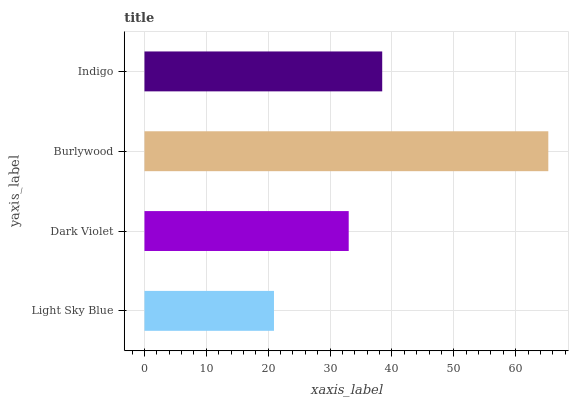Is Light Sky Blue the minimum?
Answer yes or no. Yes. Is Burlywood the maximum?
Answer yes or no. Yes. Is Dark Violet the minimum?
Answer yes or no. No. Is Dark Violet the maximum?
Answer yes or no. No. Is Dark Violet greater than Light Sky Blue?
Answer yes or no. Yes. Is Light Sky Blue less than Dark Violet?
Answer yes or no. Yes. Is Light Sky Blue greater than Dark Violet?
Answer yes or no. No. Is Dark Violet less than Light Sky Blue?
Answer yes or no. No. Is Indigo the high median?
Answer yes or no. Yes. Is Dark Violet the low median?
Answer yes or no. Yes. Is Burlywood the high median?
Answer yes or no. No. Is Indigo the low median?
Answer yes or no. No. 